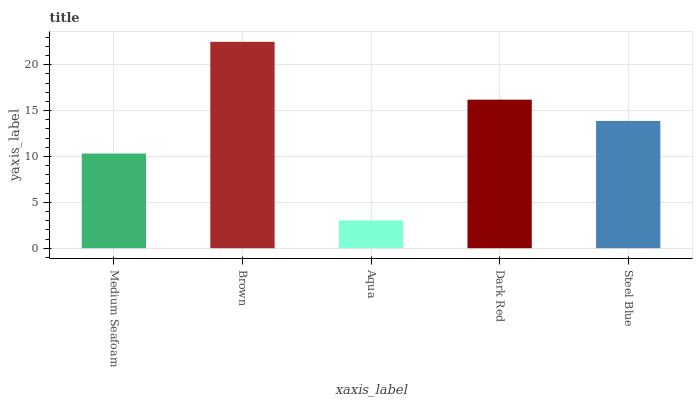Is Aqua the minimum?
Answer yes or no. Yes. Is Brown the maximum?
Answer yes or no. Yes. Is Brown the minimum?
Answer yes or no. No. Is Aqua the maximum?
Answer yes or no. No. Is Brown greater than Aqua?
Answer yes or no. Yes. Is Aqua less than Brown?
Answer yes or no. Yes. Is Aqua greater than Brown?
Answer yes or no. No. Is Brown less than Aqua?
Answer yes or no. No. Is Steel Blue the high median?
Answer yes or no. Yes. Is Steel Blue the low median?
Answer yes or no. Yes. Is Medium Seafoam the high median?
Answer yes or no. No. Is Aqua the low median?
Answer yes or no. No. 